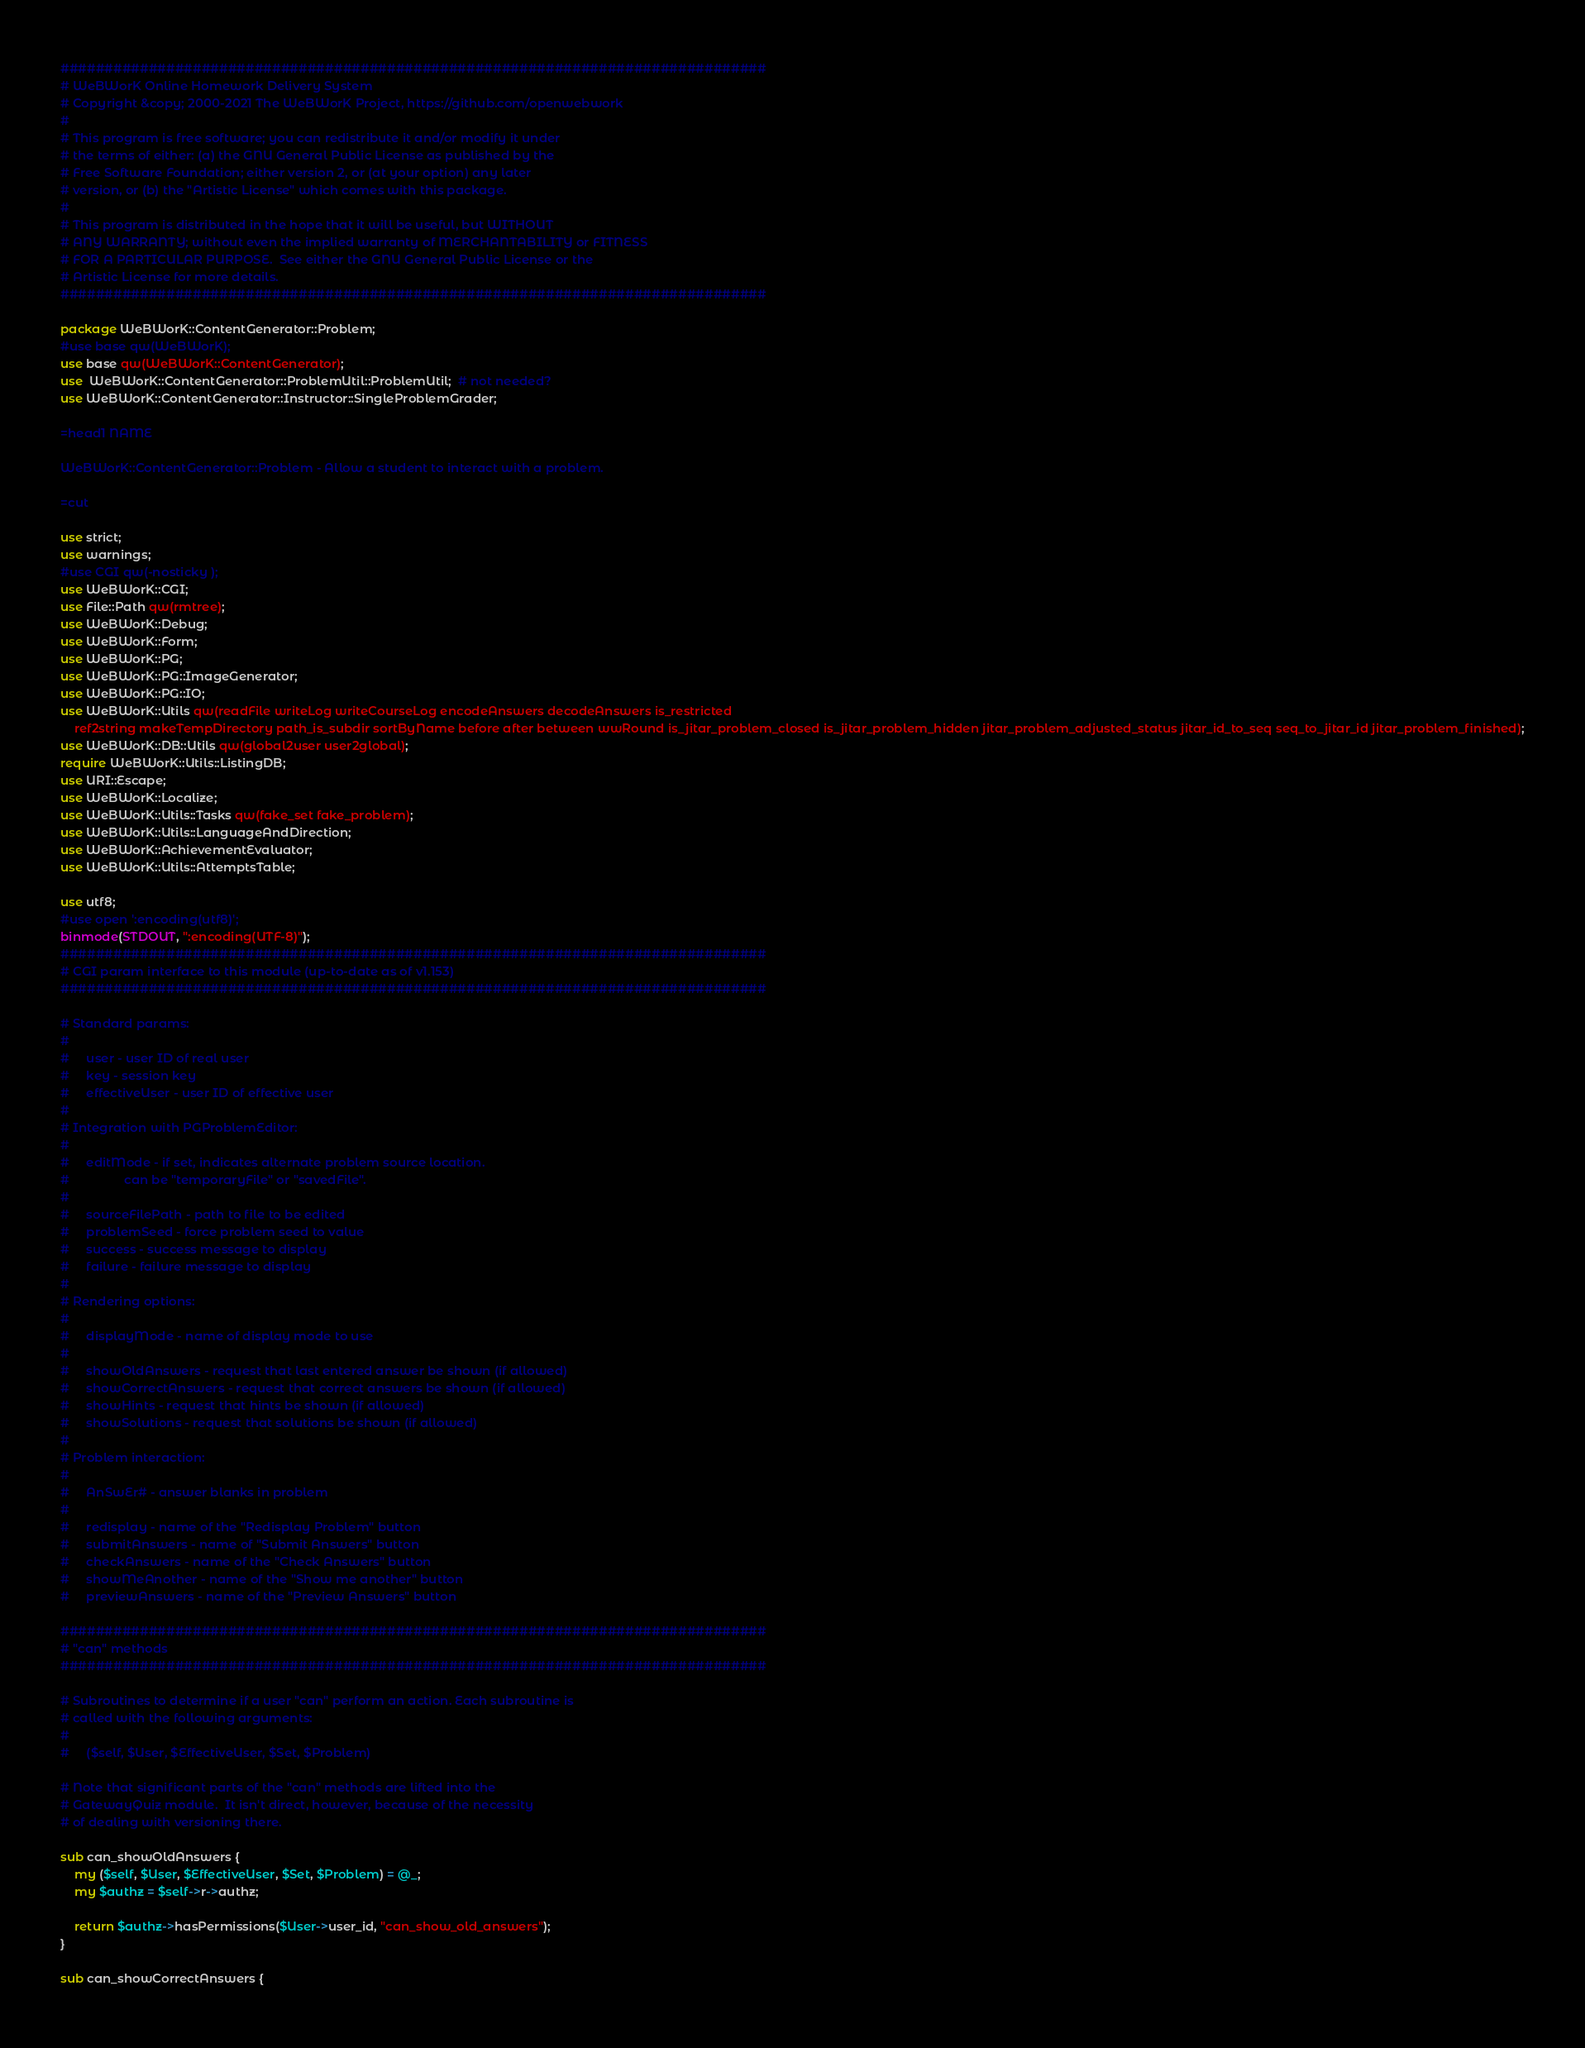Convert code to text. <code><loc_0><loc_0><loc_500><loc_500><_Perl_>################################################################################
# WeBWorK Online Homework Delivery System
# Copyright &copy; 2000-2021 The WeBWorK Project, https://github.com/openwebwork
#
# This program is free software; you can redistribute it and/or modify it under
# the terms of either: (a) the GNU General Public License as published by the
# Free Software Foundation; either version 2, or (at your option) any later
# version, or (b) the "Artistic License" which comes with this package.
#
# This program is distributed in the hope that it will be useful, but WITHOUT
# ANY WARRANTY; without even the implied warranty of MERCHANTABILITY or FITNESS
# FOR A PARTICULAR PURPOSE.  See either the GNU General Public License or the
# Artistic License for more details.
################################################################################

package WeBWorK::ContentGenerator::Problem;
#use base qw(WeBWorK);
use base qw(WeBWorK::ContentGenerator);
use  WeBWorK::ContentGenerator::ProblemUtil::ProblemUtil;  # not needed?
use WeBWorK::ContentGenerator::Instructor::SingleProblemGrader;

=head1 NAME

WeBWorK::ContentGenerator::Problem - Allow a student to interact with a problem.

=cut

use strict;
use warnings;
#use CGI qw(-nosticky );
use WeBWorK::CGI;
use File::Path qw(rmtree);
use WeBWorK::Debug;
use WeBWorK::Form;
use WeBWorK::PG;
use WeBWorK::PG::ImageGenerator;
use WeBWorK::PG::IO;
use WeBWorK::Utils qw(readFile writeLog writeCourseLog encodeAnswers decodeAnswers is_restricted
	ref2string makeTempDirectory path_is_subdir sortByName before after between wwRound is_jitar_problem_closed is_jitar_problem_hidden jitar_problem_adjusted_status jitar_id_to_seq seq_to_jitar_id jitar_problem_finished);
use WeBWorK::DB::Utils qw(global2user user2global);
require WeBWorK::Utils::ListingDB;
use URI::Escape;
use WeBWorK::Localize;
use WeBWorK::Utils::Tasks qw(fake_set fake_problem);
use WeBWorK::Utils::LanguageAndDirection;
use WeBWorK::AchievementEvaluator;
use WeBWorK::Utils::AttemptsTable;

use utf8;
#use open ':encoding(utf8)';
binmode(STDOUT, ":encoding(UTF-8)");
################################################################################
# CGI param interface to this module (up-to-date as of v1.153)
################################################################################

# Standard params:
#
#     user - user ID of real user
#     key - session key
#     effectiveUser - user ID of effective user
#
# Integration with PGProblemEditor:
#
#     editMode - if set, indicates alternate problem source location.
#                can be "temporaryFile" or "savedFile".
#
#     sourceFilePath - path to file to be edited
#     problemSeed - force problem seed to value
#     success - success message to display
#     failure - failure message to display
#
# Rendering options:
#
#     displayMode - name of display mode to use
#
#     showOldAnswers - request that last entered answer be shown (if allowed)
#     showCorrectAnswers - request that correct answers be shown (if allowed)
#     showHints - request that hints be shown (if allowed)
#     showSolutions - request that solutions be shown (if allowed)
#
# Problem interaction:
#
#     AnSwEr# - answer blanks in problem
#
#     redisplay - name of the "Redisplay Problem" button
#     submitAnswers - name of "Submit Answers" button
#     checkAnswers - name of the "Check Answers" button
#     showMeAnother - name of the "Show me another" button
#     previewAnswers - name of the "Preview Answers" button

################################################################################
# "can" methods
################################################################################

# Subroutines to determine if a user "can" perform an action. Each subroutine is
# called with the following arguments:
#
#     ($self, $User, $EffectiveUser, $Set, $Problem)

# Note that significant parts of the "can" methods are lifted into the
# GatewayQuiz module.  It isn't direct, however, because of the necessity
# of dealing with versioning there.

sub can_showOldAnswers {
	my ($self, $User, $EffectiveUser, $Set, $Problem) = @_;
	my $authz = $self->r->authz;

	return $authz->hasPermissions($User->user_id, "can_show_old_answers");
}

sub can_showCorrectAnswers {</code> 